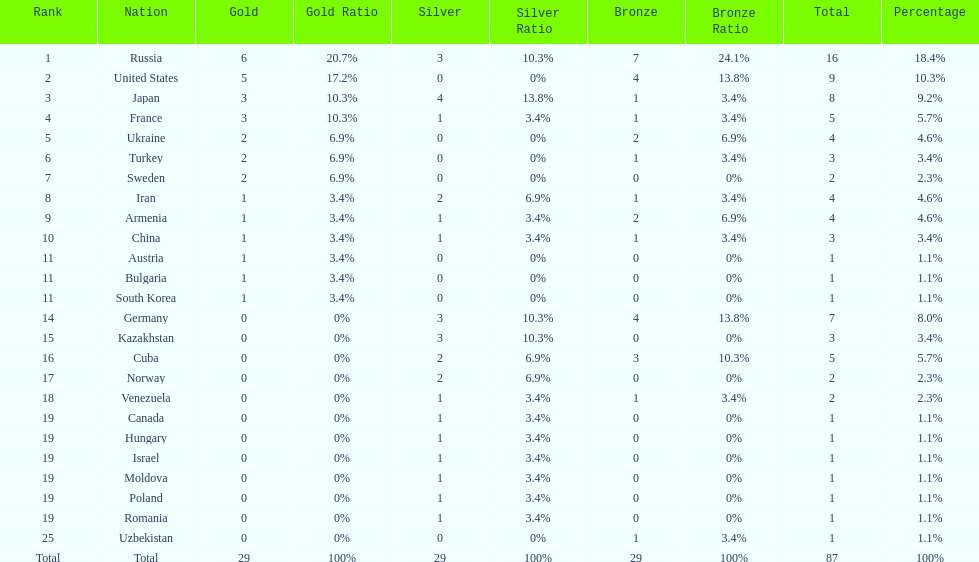Which nation has one gold medal but zero in both silver and bronze? Austria. I'm looking to parse the entire table for insights. Could you assist me with that? {'header': ['Rank', 'Nation', 'Gold', 'Gold Ratio', 'Silver', 'Silver Ratio', 'Bronze', 'Bronze Ratio', 'Total', 'Percentage'], 'rows': [['1', 'Russia', '6', '20.7%', '3', '10.3%', '7', '24.1%', '16', '18.4%'], ['2', 'United States', '5', '17.2%', '0', '0%', '4', '13.8%', '9', '10.3%'], ['3', 'Japan', '3', '10.3%', '4', '13.8%', '1', '3.4%', '8', '9.2%'], ['4', 'France', '3', '10.3%', '1', '3.4%', '1', '3.4%', '5', '5.7%'], ['5', 'Ukraine', '2', '6.9%', '0', '0%', '2', '6.9%', '4', '4.6%'], ['6', 'Turkey', '2', '6.9%', '0', '0%', '1', '3.4%', '3', '3.4%'], ['7', 'Sweden', '2', '6.9%', '0', '0%', '0', '0%', '2', '2.3%'], ['8', 'Iran', '1', '3.4%', '2', '6.9%', '1', '3.4%', '4', '4.6%'], ['9', 'Armenia', '1', '3.4%', '1', '3.4%', '2', '6.9%', '4', '4.6%'], ['10', 'China', '1', '3.4%', '1', '3.4%', '1', '3.4%', '3', '3.4%'], ['11', 'Austria', '1', '3.4%', '0', '0%', '0', '0%', '1', '1.1%'], ['11', 'Bulgaria', '1', '3.4%', '0', '0%', '0', '0%', '1', '1.1%'], ['11', 'South Korea', '1', '3.4%', '0', '0%', '0', '0%', '1', '1.1%'], ['14', 'Germany', '0', '0%', '3', '10.3%', '4', '13.8%', '7', '8.0%'], ['15', 'Kazakhstan', '0', '0%', '3', '10.3%', '0', '0%', '3', '3.4%'], ['16', 'Cuba', '0', '0%', '2', '6.9%', '3', '10.3%', '5', '5.7%'], ['17', 'Norway', '0', '0%', '2', '6.9%', '0', '0%', '2', '2.3%'], ['18', 'Venezuela', '0', '0%', '1', '3.4%', '1', '3.4%', '2', '2.3%'], ['19', 'Canada', '0', '0%', '1', '3.4%', '0', '0%', '1', '1.1%'], ['19', 'Hungary', '0', '0%', '1', '3.4%', '0', '0%', '1', '1.1%'], ['19', 'Israel', '0', '0%', '1', '3.4%', '0', '0%', '1', '1.1%'], ['19', 'Moldova', '0', '0%', '1', '3.4%', '0', '0%', '1', '1.1%'], ['19', 'Poland', '0', '0%', '1', '3.4%', '0', '0%', '1', '1.1%'], ['19', 'Romania', '0', '0%', '1', '3.4%', '0', '0%', '1', '1.1%'], ['25', 'Uzbekistan', '0', '0%', '0', '0%', '1', '3.4%', '1', '1.1%'], ['Total', 'Total', '29', '100%', '29', '100%', '29', '100%', '87', '100%']]} 